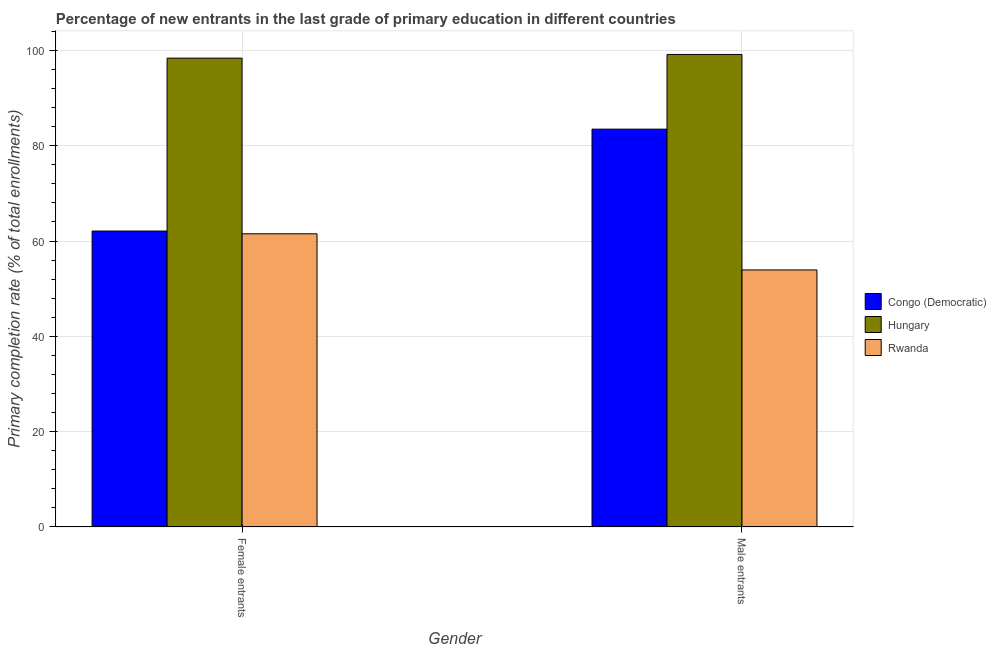How many bars are there on the 1st tick from the left?
Give a very brief answer. 3. What is the label of the 1st group of bars from the left?
Offer a terse response. Female entrants. What is the primary completion rate of male entrants in Hungary?
Your response must be concise. 99.16. Across all countries, what is the maximum primary completion rate of female entrants?
Your answer should be very brief. 98.38. Across all countries, what is the minimum primary completion rate of female entrants?
Your response must be concise. 61.52. In which country was the primary completion rate of male entrants maximum?
Provide a short and direct response. Hungary. In which country was the primary completion rate of male entrants minimum?
Keep it short and to the point. Rwanda. What is the total primary completion rate of male entrants in the graph?
Your answer should be very brief. 236.57. What is the difference between the primary completion rate of female entrants in Hungary and that in Rwanda?
Offer a terse response. 36.86. What is the difference between the primary completion rate of male entrants in Rwanda and the primary completion rate of female entrants in Congo (Democratic)?
Ensure brevity in your answer.  -8.17. What is the average primary completion rate of female entrants per country?
Provide a short and direct response. 74. What is the difference between the primary completion rate of male entrants and primary completion rate of female entrants in Hungary?
Provide a short and direct response. 0.77. What is the ratio of the primary completion rate of female entrants in Hungary to that in Rwanda?
Provide a short and direct response. 1.6. Is the primary completion rate of male entrants in Congo (Democratic) less than that in Hungary?
Ensure brevity in your answer.  Yes. In how many countries, is the primary completion rate of male entrants greater than the average primary completion rate of male entrants taken over all countries?
Your answer should be compact. 2. What does the 3rd bar from the left in Female entrants represents?
Your answer should be very brief. Rwanda. What does the 1st bar from the right in Male entrants represents?
Your answer should be compact. Rwanda. How many bars are there?
Provide a short and direct response. 6. Are all the bars in the graph horizontal?
Provide a succinct answer. No. Are the values on the major ticks of Y-axis written in scientific E-notation?
Your answer should be compact. No. Where does the legend appear in the graph?
Provide a short and direct response. Center right. How are the legend labels stacked?
Offer a very short reply. Vertical. What is the title of the graph?
Offer a very short reply. Percentage of new entrants in the last grade of primary education in different countries. Does "Hong Kong" appear as one of the legend labels in the graph?
Ensure brevity in your answer.  No. What is the label or title of the Y-axis?
Keep it short and to the point. Primary completion rate (% of total enrollments). What is the Primary completion rate (% of total enrollments) of Congo (Democratic) in Female entrants?
Your response must be concise. 62.1. What is the Primary completion rate (% of total enrollments) of Hungary in Female entrants?
Your answer should be very brief. 98.38. What is the Primary completion rate (% of total enrollments) of Rwanda in Female entrants?
Your response must be concise. 61.52. What is the Primary completion rate (% of total enrollments) in Congo (Democratic) in Male entrants?
Your answer should be compact. 83.48. What is the Primary completion rate (% of total enrollments) of Hungary in Male entrants?
Your answer should be compact. 99.16. What is the Primary completion rate (% of total enrollments) of Rwanda in Male entrants?
Provide a succinct answer. 53.94. Across all Gender, what is the maximum Primary completion rate (% of total enrollments) in Congo (Democratic)?
Your answer should be very brief. 83.48. Across all Gender, what is the maximum Primary completion rate (% of total enrollments) in Hungary?
Give a very brief answer. 99.16. Across all Gender, what is the maximum Primary completion rate (% of total enrollments) in Rwanda?
Your answer should be compact. 61.52. Across all Gender, what is the minimum Primary completion rate (% of total enrollments) of Congo (Democratic)?
Your response must be concise. 62.1. Across all Gender, what is the minimum Primary completion rate (% of total enrollments) of Hungary?
Offer a terse response. 98.38. Across all Gender, what is the minimum Primary completion rate (% of total enrollments) of Rwanda?
Your answer should be very brief. 53.94. What is the total Primary completion rate (% of total enrollments) of Congo (Democratic) in the graph?
Provide a succinct answer. 145.58. What is the total Primary completion rate (% of total enrollments) of Hungary in the graph?
Your answer should be very brief. 197.54. What is the total Primary completion rate (% of total enrollments) in Rwanda in the graph?
Ensure brevity in your answer.  115.46. What is the difference between the Primary completion rate (% of total enrollments) of Congo (Democratic) in Female entrants and that in Male entrants?
Your answer should be compact. -21.38. What is the difference between the Primary completion rate (% of total enrollments) of Hungary in Female entrants and that in Male entrants?
Give a very brief answer. -0.77. What is the difference between the Primary completion rate (% of total enrollments) of Rwanda in Female entrants and that in Male entrants?
Ensure brevity in your answer.  7.59. What is the difference between the Primary completion rate (% of total enrollments) in Congo (Democratic) in Female entrants and the Primary completion rate (% of total enrollments) in Hungary in Male entrants?
Give a very brief answer. -37.05. What is the difference between the Primary completion rate (% of total enrollments) in Congo (Democratic) in Female entrants and the Primary completion rate (% of total enrollments) in Rwanda in Male entrants?
Your response must be concise. 8.17. What is the difference between the Primary completion rate (% of total enrollments) of Hungary in Female entrants and the Primary completion rate (% of total enrollments) of Rwanda in Male entrants?
Your answer should be very brief. 44.45. What is the average Primary completion rate (% of total enrollments) of Congo (Democratic) per Gender?
Make the answer very short. 72.79. What is the average Primary completion rate (% of total enrollments) in Hungary per Gender?
Keep it short and to the point. 98.77. What is the average Primary completion rate (% of total enrollments) in Rwanda per Gender?
Keep it short and to the point. 57.73. What is the difference between the Primary completion rate (% of total enrollments) of Congo (Democratic) and Primary completion rate (% of total enrollments) of Hungary in Female entrants?
Ensure brevity in your answer.  -36.28. What is the difference between the Primary completion rate (% of total enrollments) in Congo (Democratic) and Primary completion rate (% of total enrollments) in Rwanda in Female entrants?
Your answer should be compact. 0.58. What is the difference between the Primary completion rate (% of total enrollments) of Hungary and Primary completion rate (% of total enrollments) of Rwanda in Female entrants?
Give a very brief answer. 36.86. What is the difference between the Primary completion rate (% of total enrollments) in Congo (Democratic) and Primary completion rate (% of total enrollments) in Hungary in Male entrants?
Provide a short and direct response. -15.67. What is the difference between the Primary completion rate (% of total enrollments) in Congo (Democratic) and Primary completion rate (% of total enrollments) in Rwanda in Male entrants?
Your response must be concise. 29.54. What is the difference between the Primary completion rate (% of total enrollments) of Hungary and Primary completion rate (% of total enrollments) of Rwanda in Male entrants?
Give a very brief answer. 45.22. What is the ratio of the Primary completion rate (% of total enrollments) of Congo (Democratic) in Female entrants to that in Male entrants?
Your answer should be very brief. 0.74. What is the ratio of the Primary completion rate (% of total enrollments) of Rwanda in Female entrants to that in Male entrants?
Offer a very short reply. 1.14. What is the difference between the highest and the second highest Primary completion rate (% of total enrollments) of Congo (Democratic)?
Provide a short and direct response. 21.38. What is the difference between the highest and the second highest Primary completion rate (% of total enrollments) of Hungary?
Offer a very short reply. 0.77. What is the difference between the highest and the second highest Primary completion rate (% of total enrollments) in Rwanda?
Your answer should be compact. 7.59. What is the difference between the highest and the lowest Primary completion rate (% of total enrollments) in Congo (Democratic)?
Offer a very short reply. 21.38. What is the difference between the highest and the lowest Primary completion rate (% of total enrollments) in Hungary?
Your answer should be very brief. 0.77. What is the difference between the highest and the lowest Primary completion rate (% of total enrollments) in Rwanda?
Offer a terse response. 7.59. 